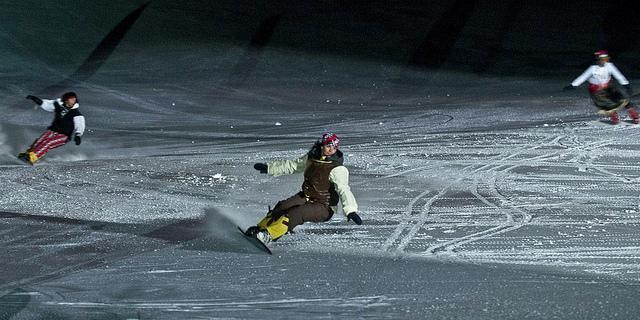How many people are there?
Give a very brief answer. 3. How many people are in the picture?
Give a very brief answer. 3. 